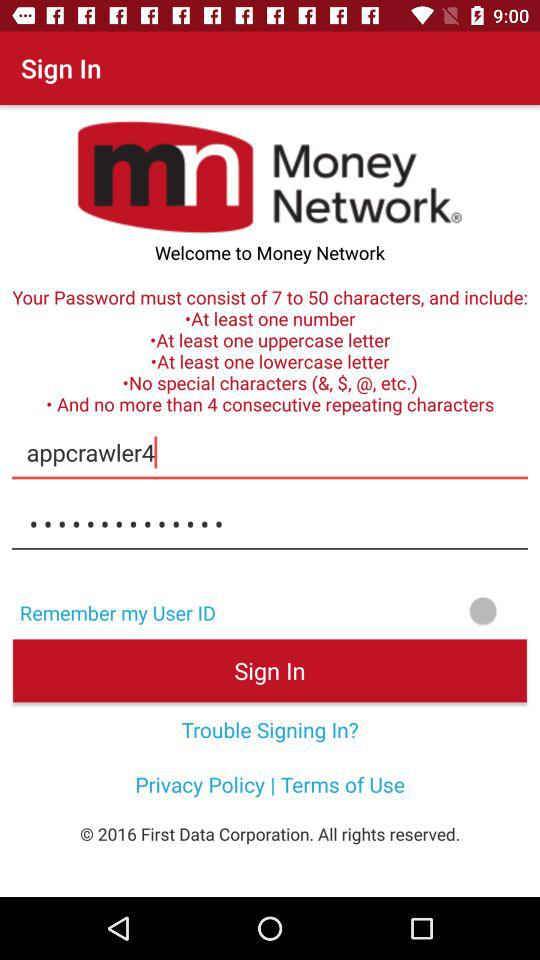What is the criteria for setting a password? The criteria for setting a password are "must consist of 7 to 50 characters", "At least one number", "At least one uppercase letter", "At least one lowercase letter", "No special characters (&, $, @, etc.)" and "no more than 4 consecutive repeating characters". 